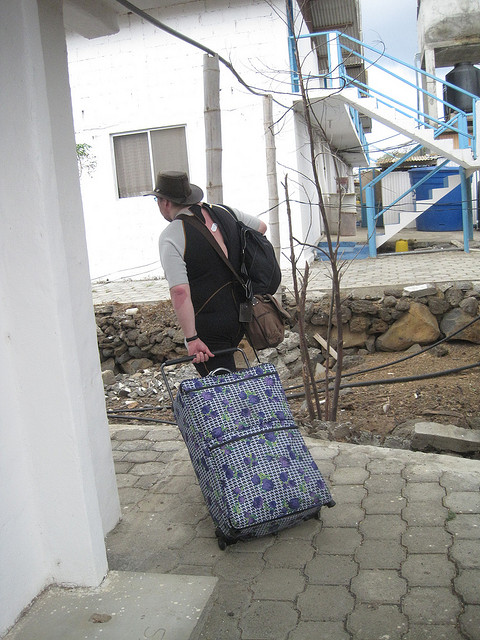<image>Is he going on a trip? I don't know if he is going on a trip. Is he going on a trip? I don't know if he is going on a trip. It is possible that he is going on a trip, but I am not certain. 